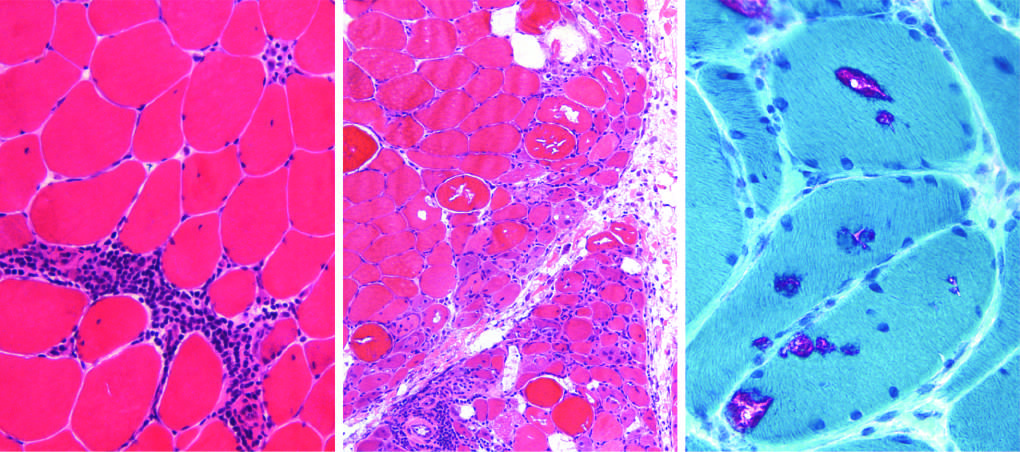does dermatomyositis show prominent perifascicular and paraseptal atrophy?
Answer the question using a single word or phrase. Yes 